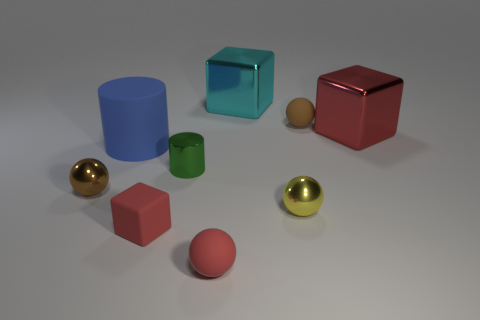Subtract all red cubes. How many were subtracted if there are1red cubes left? 1 Subtract all big shiny blocks. How many blocks are left? 1 Subtract all blue blocks. How many brown spheres are left? 2 Add 1 small blue matte cylinders. How many objects exist? 10 Subtract 1 blocks. How many blocks are left? 2 Subtract all red spheres. How many spheres are left? 3 Subtract all purple spheres. Subtract all yellow cylinders. How many spheres are left? 4 Add 9 cyan rubber spheres. How many cyan rubber spheres exist? 9 Subtract 0 red cylinders. How many objects are left? 9 Subtract all blocks. How many objects are left? 6 